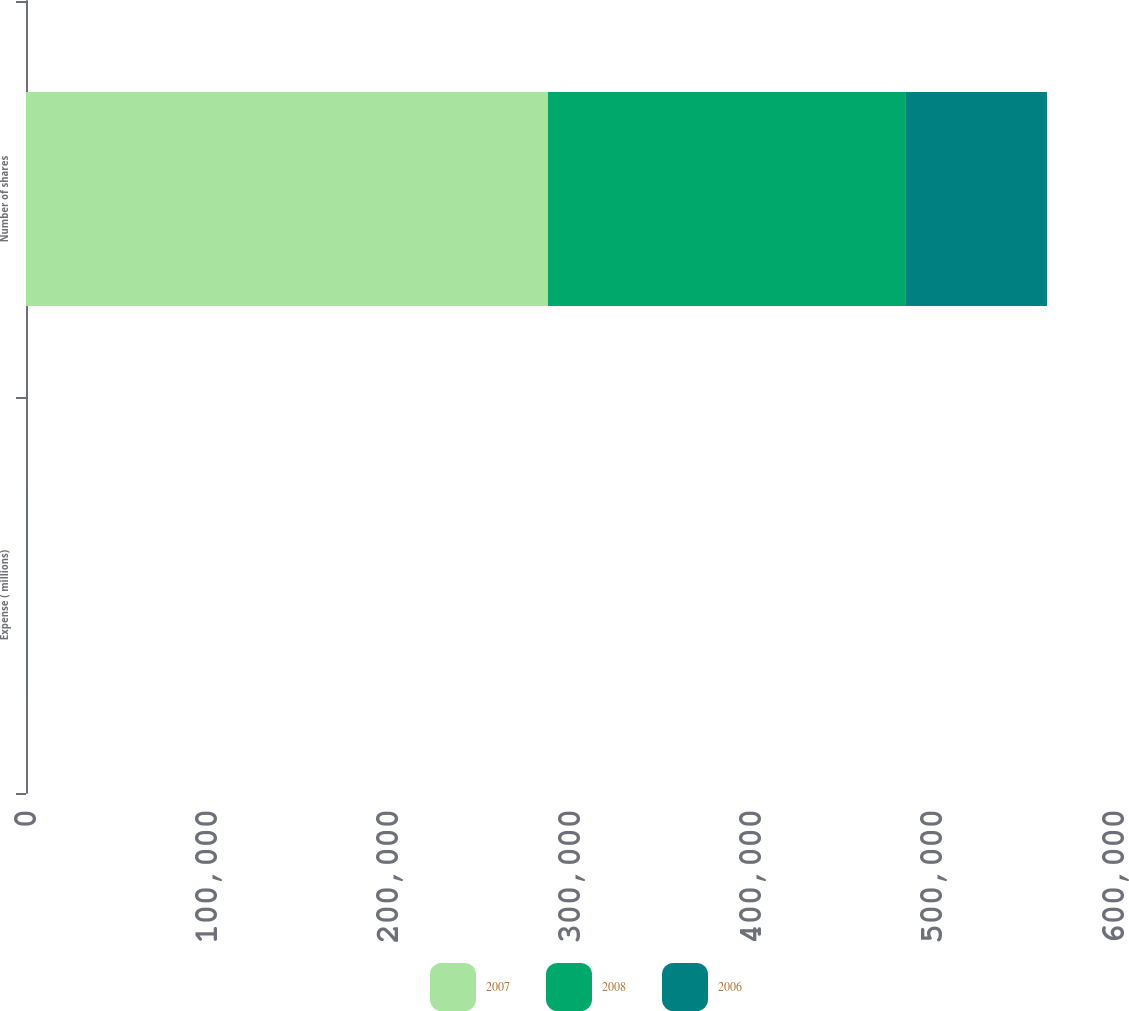<chart> <loc_0><loc_0><loc_500><loc_500><stacked_bar_chart><ecel><fcel>Expense ( millions)<fcel>Number of shares<nl><fcel>2007<fcel>4.3<fcel>287816<nl><fcel>2008<fcel>17.1<fcel>197052<nl><fcel>2006<fcel>2.2<fcel>78170<nl></chart> 